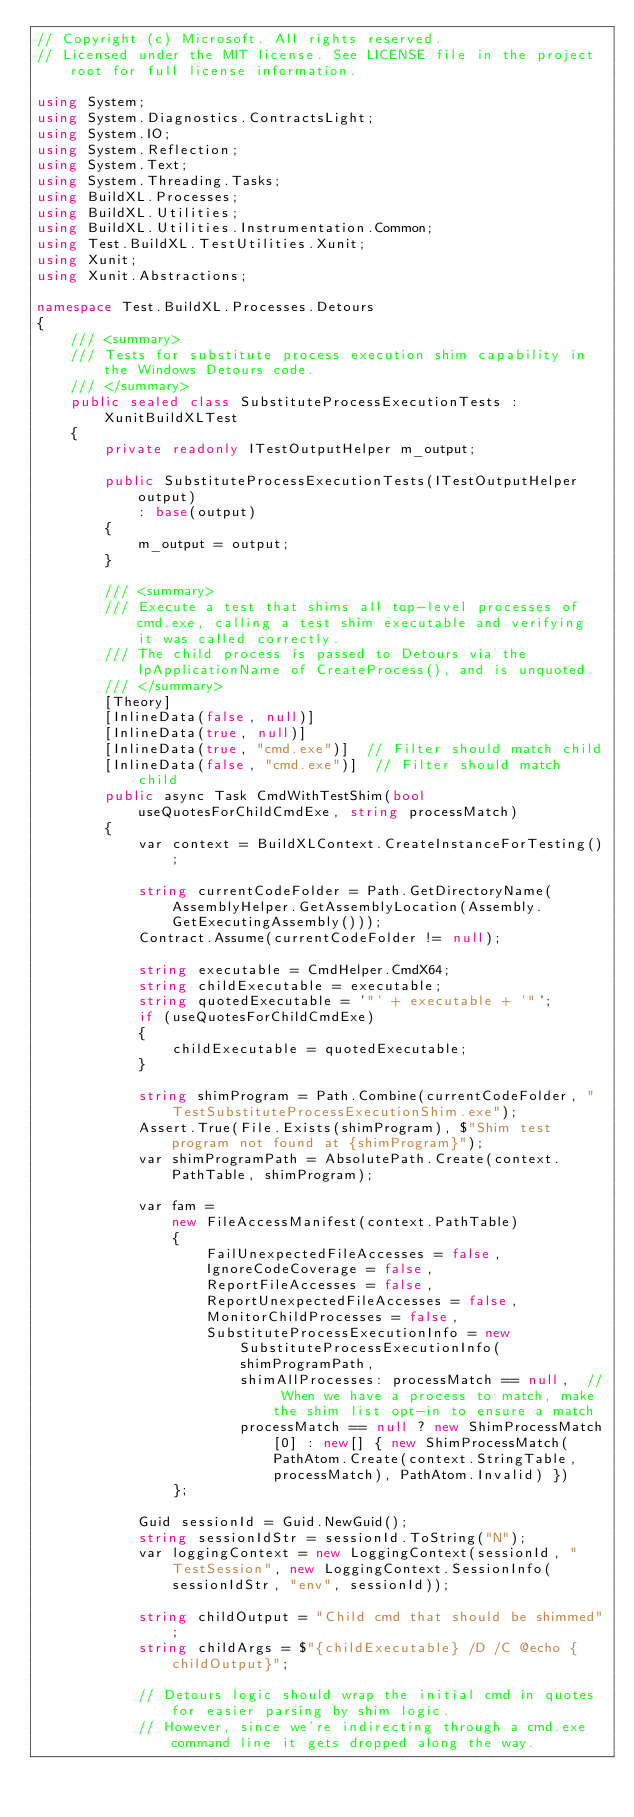<code> <loc_0><loc_0><loc_500><loc_500><_C#_>// Copyright (c) Microsoft. All rights reserved.
// Licensed under the MIT license. See LICENSE file in the project root for full license information.

using System;
using System.Diagnostics.ContractsLight;
using System.IO;
using System.Reflection;
using System.Text;
using System.Threading.Tasks;
using BuildXL.Processes;
using BuildXL.Utilities;
using BuildXL.Utilities.Instrumentation.Common;
using Test.BuildXL.TestUtilities.Xunit;
using Xunit;
using Xunit.Abstractions;

namespace Test.BuildXL.Processes.Detours
{
    /// <summary>
    /// Tests for substitute process execution shim capability in the Windows Detours code.
    /// </summary>
    public sealed class SubstituteProcessExecutionTests : XunitBuildXLTest
    {
        private readonly ITestOutputHelper m_output;

        public SubstituteProcessExecutionTests(ITestOutputHelper output)
            : base(output)
        {
            m_output = output;
        }

        /// <summary>
        /// Execute a test that shims all top-level processes of cmd.exe, calling a test shim executable and verifying it was called correctly.
        /// The child process is passed to Detours via the lpApplicationName of CreateProcess(), and is unquoted.
        /// </summary>
        [Theory]
        [InlineData(false, null)]
        [InlineData(true, null)]
        [InlineData(true, "cmd.exe")]  // Filter should match child
        [InlineData(false, "cmd.exe")]  // Filter should match child
        public async Task CmdWithTestShim(bool useQuotesForChildCmdExe, string processMatch)
        {
            var context = BuildXLContext.CreateInstanceForTesting();

            string currentCodeFolder = Path.GetDirectoryName(AssemblyHelper.GetAssemblyLocation(Assembly.GetExecutingAssembly()));
            Contract.Assume(currentCodeFolder != null);

            string executable = CmdHelper.CmdX64;
            string childExecutable = executable;
            string quotedExecutable = '"' + executable + '"';
            if (useQuotesForChildCmdExe)
            {
                childExecutable = quotedExecutable;
            }

            string shimProgram = Path.Combine(currentCodeFolder, "TestSubstituteProcessExecutionShim.exe");
            Assert.True(File.Exists(shimProgram), $"Shim test program not found at {shimProgram}");
            var shimProgramPath = AbsolutePath.Create(context.PathTable, shimProgram);
            
            var fam =
                new FileAccessManifest(context.PathTable)
                {
                    FailUnexpectedFileAccesses = false,
                    IgnoreCodeCoverage = false,
                    ReportFileAccesses = false,
                    ReportUnexpectedFileAccesses = false,
                    MonitorChildProcesses = false,
                    SubstituteProcessExecutionInfo = new SubstituteProcessExecutionInfo(
                        shimProgramPath,
                        shimAllProcesses: processMatch == null,  // When we have a process to match, make the shim list opt-in to ensure a match
                        processMatch == null ? new ShimProcessMatch[0] : new[] { new ShimProcessMatch(PathAtom.Create(context.StringTable, processMatch), PathAtom.Invalid) })
                };

            Guid sessionId = Guid.NewGuid();
            string sessionIdStr = sessionId.ToString("N");
            var loggingContext = new LoggingContext(sessionId, "TestSession", new LoggingContext.SessionInfo(sessionIdStr, "env", sessionId));

            string childOutput = "Child cmd that should be shimmed";
            string childArgs = $"{childExecutable} /D /C @echo {childOutput}";

            // Detours logic should wrap the initial cmd in quotes for easier parsing by shim logic.
            // However, since we're indirecting through a cmd.exe command line it gets dropped along the way.</code> 